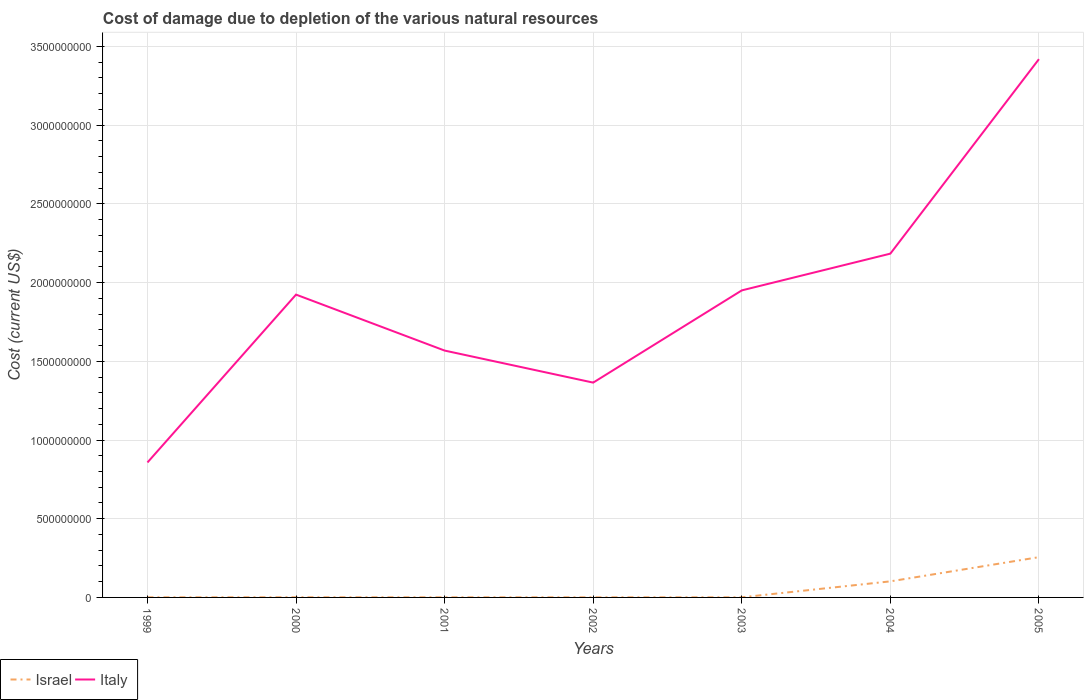Is the number of lines equal to the number of legend labels?
Your answer should be very brief. Yes. Across all years, what is the maximum cost of damage caused due to the depletion of various natural resources in Israel?
Your response must be concise. 6.60e+05. In which year was the cost of damage caused due to the depletion of various natural resources in Israel maximum?
Provide a short and direct response. 2002. What is the total cost of damage caused due to the depletion of various natural resources in Israel in the graph?
Your answer should be compact. -2.66e+04. What is the difference between the highest and the second highest cost of damage caused due to the depletion of various natural resources in Israel?
Your response must be concise. 2.55e+08. How many lines are there?
Give a very brief answer. 2. What is the difference between two consecutive major ticks on the Y-axis?
Make the answer very short. 5.00e+08. Are the values on the major ticks of Y-axis written in scientific E-notation?
Ensure brevity in your answer.  No. Where does the legend appear in the graph?
Your answer should be compact. Bottom left. How many legend labels are there?
Keep it short and to the point. 2. How are the legend labels stacked?
Offer a very short reply. Horizontal. What is the title of the graph?
Make the answer very short. Cost of damage due to depletion of the various natural resources. Does "Liechtenstein" appear as one of the legend labels in the graph?
Ensure brevity in your answer.  No. What is the label or title of the X-axis?
Your response must be concise. Years. What is the label or title of the Y-axis?
Your response must be concise. Cost (current US$). What is the Cost (current US$) in Israel in 1999?
Give a very brief answer. 7.40e+05. What is the Cost (current US$) of Italy in 1999?
Keep it short and to the point. 8.57e+08. What is the Cost (current US$) of Israel in 2000?
Provide a succinct answer. 9.99e+05. What is the Cost (current US$) in Italy in 2000?
Your answer should be very brief. 1.92e+09. What is the Cost (current US$) in Israel in 2001?
Provide a succinct answer. 7.47e+05. What is the Cost (current US$) of Italy in 2001?
Keep it short and to the point. 1.57e+09. What is the Cost (current US$) in Israel in 2002?
Provide a short and direct response. 6.60e+05. What is the Cost (current US$) of Italy in 2002?
Provide a succinct answer. 1.36e+09. What is the Cost (current US$) in Israel in 2003?
Your response must be concise. 7.74e+05. What is the Cost (current US$) in Italy in 2003?
Your response must be concise. 1.95e+09. What is the Cost (current US$) of Israel in 2004?
Offer a very short reply. 1.02e+08. What is the Cost (current US$) in Italy in 2004?
Make the answer very short. 2.18e+09. What is the Cost (current US$) of Israel in 2005?
Provide a short and direct response. 2.56e+08. What is the Cost (current US$) of Italy in 2005?
Make the answer very short. 3.42e+09. Across all years, what is the maximum Cost (current US$) in Israel?
Give a very brief answer. 2.56e+08. Across all years, what is the maximum Cost (current US$) in Italy?
Your answer should be compact. 3.42e+09. Across all years, what is the minimum Cost (current US$) of Israel?
Offer a terse response. 6.60e+05. Across all years, what is the minimum Cost (current US$) in Italy?
Your response must be concise. 8.57e+08. What is the total Cost (current US$) of Israel in the graph?
Ensure brevity in your answer.  3.62e+08. What is the total Cost (current US$) of Italy in the graph?
Your answer should be compact. 1.33e+1. What is the difference between the Cost (current US$) of Israel in 1999 and that in 2000?
Provide a succinct answer. -2.59e+05. What is the difference between the Cost (current US$) of Italy in 1999 and that in 2000?
Keep it short and to the point. -1.07e+09. What is the difference between the Cost (current US$) in Israel in 1999 and that in 2001?
Offer a terse response. -7666.24. What is the difference between the Cost (current US$) in Italy in 1999 and that in 2001?
Provide a short and direct response. -7.11e+08. What is the difference between the Cost (current US$) of Israel in 1999 and that in 2002?
Your answer should be compact. 7.97e+04. What is the difference between the Cost (current US$) in Italy in 1999 and that in 2002?
Your answer should be very brief. -5.07e+08. What is the difference between the Cost (current US$) in Israel in 1999 and that in 2003?
Offer a terse response. -3.42e+04. What is the difference between the Cost (current US$) in Italy in 1999 and that in 2003?
Ensure brevity in your answer.  -1.09e+09. What is the difference between the Cost (current US$) of Israel in 1999 and that in 2004?
Keep it short and to the point. -1.01e+08. What is the difference between the Cost (current US$) of Italy in 1999 and that in 2004?
Provide a succinct answer. -1.33e+09. What is the difference between the Cost (current US$) of Israel in 1999 and that in 2005?
Ensure brevity in your answer.  -2.55e+08. What is the difference between the Cost (current US$) in Italy in 1999 and that in 2005?
Ensure brevity in your answer.  -2.56e+09. What is the difference between the Cost (current US$) in Israel in 2000 and that in 2001?
Your response must be concise. 2.52e+05. What is the difference between the Cost (current US$) in Italy in 2000 and that in 2001?
Keep it short and to the point. 3.55e+08. What is the difference between the Cost (current US$) in Israel in 2000 and that in 2002?
Provide a succinct answer. 3.39e+05. What is the difference between the Cost (current US$) in Italy in 2000 and that in 2002?
Your answer should be compact. 5.59e+08. What is the difference between the Cost (current US$) in Israel in 2000 and that in 2003?
Provide a short and direct response. 2.25e+05. What is the difference between the Cost (current US$) in Italy in 2000 and that in 2003?
Offer a terse response. -2.68e+07. What is the difference between the Cost (current US$) of Israel in 2000 and that in 2004?
Ensure brevity in your answer.  -1.01e+08. What is the difference between the Cost (current US$) of Italy in 2000 and that in 2004?
Make the answer very short. -2.60e+08. What is the difference between the Cost (current US$) of Israel in 2000 and that in 2005?
Your answer should be compact. -2.55e+08. What is the difference between the Cost (current US$) of Italy in 2000 and that in 2005?
Offer a terse response. -1.50e+09. What is the difference between the Cost (current US$) in Israel in 2001 and that in 2002?
Provide a succinct answer. 8.73e+04. What is the difference between the Cost (current US$) of Italy in 2001 and that in 2002?
Give a very brief answer. 2.04e+08. What is the difference between the Cost (current US$) in Israel in 2001 and that in 2003?
Ensure brevity in your answer.  -2.66e+04. What is the difference between the Cost (current US$) of Italy in 2001 and that in 2003?
Your answer should be very brief. -3.82e+08. What is the difference between the Cost (current US$) in Israel in 2001 and that in 2004?
Give a very brief answer. -1.01e+08. What is the difference between the Cost (current US$) of Italy in 2001 and that in 2004?
Keep it short and to the point. -6.16e+08. What is the difference between the Cost (current US$) of Israel in 2001 and that in 2005?
Provide a succinct answer. -2.55e+08. What is the difference between the Cost (current US$) of Italy in 2001 and that in 2005?
Your answer should be compact. -1.85e+09. What is the difference between the Cost (current US$) in Israel in 2002 and that in 2003?
Provide a short and direct response. -1.14e+05. What is the difference between the Cost (current US$) of Italy in 2002 and that in 2003?
Provide a short and direct response. -5.86e+08. What is the difference between the Cost (current US$) in Israel in 2002 and that in 2004?
Provide a short and direct response. -1.01e+08. What is the difference between the Cost (current US$) of Italy in 2002 and that in 2004?
Keep it short and to the point. -8.19e+08. What is the difference between the Cost (current US$) in Israel in 2002 and that in 2005?
Provide a succinct answer. -2.55e+08. What is the difference between the Cost (current US$) of Italy in 2002 and that in 2005?
Your answer should be very brief. -2.05e+09. What is the difference between the Cost (current US$) in Israel in 2003 and that in 2004?
Your answer should be very brief. -1.01e+08. What is the difference between the Cost (current US$) in Italy in 2003 and that in 2004?
Provide a short and direct response. -2.33e+08. What is the difference between the Cost (current US$) of Israel in 2003 and that in 2005?
Make the answer very short. -2.55e+08. What is the difference between the Cost (current US$) of Italy in 2003 and that in 2005?
Keep it short and to the point. -1.47e+09. What is the difference between the Cost (current US$) in Israel in 2004 and that in 2005?
Your answer should be very brief. -1.54e+08. What is the difference between the Cost (current US$) of Italy in 2004 and that in 2005?
Your answer should be very brief. -1.24e+09. What is the difference between the Cost (current US$) in Israel in 1999 and the Cost (current US$) in Italy in 2000?
Your response must be concise. -1.92e+09. What is the difference between the Cost (current US$) of Israel in 1999 and the Cost (current US$) of Italy in 2001?
Ensure brevity in your answer.  -1.57e+09. What is the difference between the Cost (current US$) of Israel in 1999 and the Cost (current US$) of Italy in 2002?
Provide a short and direct response. -1.36e+09. What is the difference between the Cost (current US$) in Israel in 1999 and the Cost (current US$) in Italy in 2003?
Your response must be concise. -1.95e+09. What is the difference between the Cost (current US$) of Israel in 1999 and the Cost (current US$) of Italy in 2004?
Provide a succinct answer. -2.18e+09. What is the difference between the Cost (current US$) in Israel in 1999 and the Cost (current US$) in Italy in 2005?
Make the answer very short. -3.42e+09. What is the difference between the Cost (current US$) of Israel in 2000 and the Cost (current US$) of Italy in 2001?
Ensure brevity in your answer.  -1.57e+09. What is the difference between the Cost (current US$) of Israel in 2000 and the Cost (current US$) of Italy in 2002?
Offer a very short reply. -1.36e+09. What is the difference between the Cost (current US$) in Israel in 2000 and the Cost (current US$) in Italy in 2003?
Your response must be concise. -1.95e+09. What is the difference between the Cost (current US$) in Israel in 2000 and the Cost (current US$) in Italy in 2004?
Offer a very short reply. -2.18e+09. What is the difference between the Cost (current US$) in Israel in 2000 and the Cost (current US$) in Italy in 2005?
Your response must be concise. -3.42e+09. What is the difference between the Cost (current US$) in Israel in 2001 and the Cost (current US$) in Italy in 2002?
Provide a succinct answer. -1.36e+09. What is the difference between the Cost (current US$) in Israel in 2001 and the Cost (current US$) in Italy in 2003?
Offer a very short reply. -1.95e+09. What is the difference between the Cost (current US$) of Israel in 2001 and the Cost (current US$) of Italy in 2004?
Your answer should be very brief. -2.18e+09. What is the difference between the Cost (current US$) of Israel in 2001 and the Cost (current US$) of Italy in 2005?
Keep it short and to the point. -3.42e+09. What is the difference between the Cost (current US$) of Israel in 2002 and the Cost (current US$) of Italy in 2003?
Keep it short and to the point. -1.95e+09. What is the difference between the Cost (current US$) of Israel in 2002 and the Cost (current US$) of Italy in 2004?
Keep it short and to the point. -2.18e+09. What is the difference between the Cost (current US$) of Israel in 2002 and the Cost (current US$) of Italy in 2005?
Provide a short and direct response. -3.42e+09. What is the difference between the Cost (current US$) in Israel in 2003 and the Cost (current US$) in Italy in 2004?
Offer a very short reply. -2.18e+09. What is the difference between the Cost (current US$) in Israel in 2003 and the Cost (current US$) in Italy in 2005?
Ensure brevity in your answer.  -3.42e+09. What is the difference between the Cost (current US$) of Israel in 2004 and the Cost (current US$) of Italy in 2005?
Offer a very short reply. -3.32e+09. What is the average Cost (current US$) in Israel per year?
Your answer should be very brief. 5.17e+07. What is the average Cost (current US$) in Italy per year?
Give a very brief answer. 1.90e+09. In the year 1999, what is the difference between the Cost (current US$) of Israel and Cost (current US$) of Italy?
Offer a very short reply. -8.57e+08. In the year 2000, what is the difference between the Cost (current US$) of Israel and Cost (current US$) of Italy?
Give a very brief answer. -1.92e+09. In the year 2001, what is the difference between the Cost (current US$) of Israel and Cost (current US$) of Italy?
Your answer should be very brief. -1.57e+09. In the year 2002, what is the difference between the Cost (current US$) in Israel and Cost (current US$) in Italy?
Your answer should be compact. -1.36e+09. In the year 2003, what is the difference between the Cost (current US$) in Israel and Cost (current US$) in Italy?
Your answer should be very brief. -1.95e+09. In the year 2004, what is the difference between the Cost (current US$) of Israel and Cost (current US$) of Italy?
Provide a short and direct response. -2.08e+09. In the year 2005, what is the difference between the Cost (current US$) of Israel and Cost (current US$) of Italy?
Provide a succinct answer. -3.16e+09. What is the ratio of the Cost (current US$) of Israel in 1999 to that in 2000?
Your answer should be compact. 0.74. What is the ratio of the Cost (current US$) of Italy in 1999 to that in 2000?
Your answer should be very brief. 0.45. What is the ratio of the Cost (current US$) of Israel in 1999 to that in 2001?
Provide a succinct answer. 0.99. What is the ratio of the Cost (current US$) of Italy in 1999 to that in 2001?
Keep it short and to the point. 0.55. What is the ratio of the Cost (current US$) in Israel in 1999 to that in 2002?
Your response must be concise. 1.12. What is the ratio of the Cost (current US$) of Italy in 1999 to that in 2002?
Offer a very short reply. 0.63. What is the ratio of the Cost (current US$) in Israel in 1999 to that in 2003?
Keep it short and to the point. 0.96. What is the ratio of the Cost (current US$) in Italy in 1999 to that in 2003?
Ensure brevity in your answer.  0.44. What is the ratio of the Cost (current US$) of Israel in 1999 to that in 2004?
Ensure brevity in your answer.  0.01. What is the ratio of the Cost (current US$) of Italy in 1999 to that in 2004?
Provide a succinct answer. 0.39. What is the ratio of the Cost (current US$) of Israel in 1999 to that in 2005?
Your response must be concise. 0. What is the ratio of the Cost (current US$) of Italy in 1999 to that in 2005?
Ensure brevity in your answer.  0.25. What is the ratio of the Cost (current US$) of Israel in 2000 to that in 2001?
Provide a short and direct response. 1.34. What is the ratio of the Cost (current US$) in Italy in 2000 to that in 2001?
Give a very brief answer. 1.23. What is the ratio of the Cost (current US$) in Israel in 2000 to that in 2002?
Provide a short and direct response. 1.51. What is the ratio of the Cost (current US$) of Italy in 2000 to that in 2002?
Offer a terse response. 1.41. What is the ratio of the Cost (current US$) in Israel in 2000 to that in 2003?
Provide a short and direct response. 1.29. What is the ratio of the Cost (current US$) in Italy in 2000 to that in 2003?
Your answer should be compact. 0.99. What is the ratio of the Cost (current US$) in Israel in 2000 to that in 2004?
Your answer should be compact. 0.01. What is the ratio of the Cost (current US$) of Italy in 2000 to that in 2004?
Provide a short and direct response. 0.88. What is the ratio of the Cost (current US$) of Israel in 2000 to that in 2005?
Ensure brevity in your answer.  0. What is the ratio of the Cost (current US$) in Italy in 2000 to that in 2005?
Provide a short and direct response. 0.56. What is the ratio of the Cost (current US$) in Israel in 2001 to that in 2002?
Give a very brief answer. 1.13. What is the ratio of the Cost (current US$) in Italy in 2001 to that in 2002?
Offer a terse response. 1.15. What is the ratio of the Cost (current US$) of Israel in 2001 to that in 2003?
Your answer should be very brief. 0.97. What is the ratio of the Cost (current US$) in Italy in 2001 to that in 2003?
Your answer should be very brief. 0.8. What is the ratio of the Cost (current US$) of Israel in 2001 to that in 2004?
Your response must be concise. 0.01. What is the ratio of the Cost (current US$) in Italy in 2001 to that in 2004?
Offer a very short reply. 0.72. What is the ratio of the Cost (current US$) of Israel in 2001 to that in 2005?
Your answer should be compact. 0. What is the ratio of the Cost (current US$) of Italy in 2001 to that in 2005?
Your response must be concise. 0.46. What is the ratio of the Cost (current US$) of Israel in 2002 to that in 2003?
Provide a short and direct response. 0.85. What is the ratio of the Cost (current US$) in Italy in 2002 to that in 2003?
Ensure brevity in your answer.  0.7. What is the ratio of the Cost (current US$) of Israel in 2002 to that in 2004?
Your answer should be very brief. 0.01. What is the ratio of the Cost (current US$) in Italy in 2002 to that in 2004?
Your answer should be compact. 0.62. What is the ratio of the Cost (current US$) of Israel in 2002 to that in 2005?
Your response must be concise. 0. What is the ratio of the Cost (current US$) in Italy in 2002 to that in 2005?
Offer a very short reply. 0.4. What is the ratio of the Cost (current US$) of Israel in 2003 to that in 2004?
Your response must be concise. 0.01. What is the ratio of the Cost (current US$) of Italy in 2003 to that in 2004?
Provide a short and direct response. 0.89. What is the ratio of the Cost (current US$) of Israel in 2003 to that in 2005?
Ensure brevity in your answer.  0. What is the ratio of the Cost (current US$) in Italy in 2003 to that in 2005?
Provide a short and direct response. 0.57. What is the ratio of the Cost (current US$) of Israel in 2004 to that in 2005?
Make the answer very short. 0.4. What is the ratio of the Cost (current US$) in Italy in 2004 to that in 2005?
Your answer should be very brief. 0.64. What is the difference between the highest and the second highest Cost (current US$) of Israel?
Provide a short and direct response. 1.54e+08. What is the difference between the highest and the second highest Cost (current US$) of Italy?
Ensure brevity in your answer.  1.24e+09. What is the difference between the highest and the lowest Cost (current US$) in Israel?
Make the answer very short. 2.55e+08. What is the difference between the highest and the lowest Cost (current US$) in Italy?
Ensure brevity in your answer.  2.56e+09. 